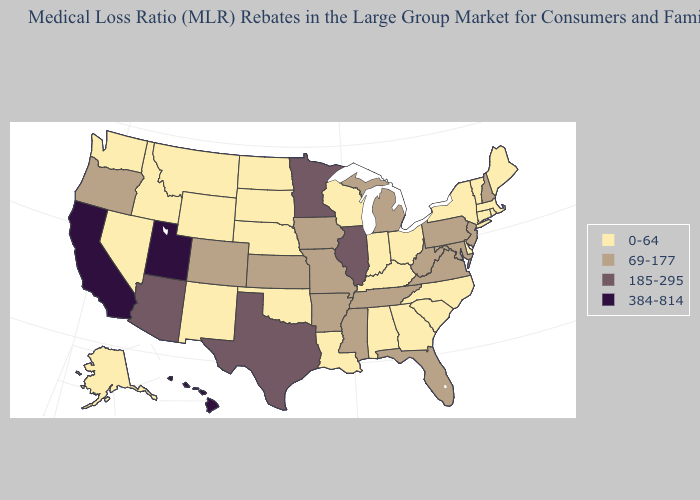Which states hav the highest value in the Northeast?
Short answer required. New Hampshire, New Jersey, Pennsylvania. Name the states that have a value in the range 0-64?
Be succinct. Alabama, Alaska, Connecticut, Delaware, Georgia, Idaho, Indiana, Kentucky, Louisiana, Maine, Massachusetts, Montana, Nebraska, Nevada, New Mexico, New York, North Carolina, North Dakota, Ohio, Oklahoma, Rhode Island, South Carolina, South Dakota, Vermont, Washington, Wisconsin, Wyoming. Does the map have missing data?
Quick response, please. No. Which states have the lowest value in the USA?
Be succinct. Alabama, Alaska, Connecticut, Delaware, Georgia, Idaho, Indiana, Kentucky, Louisiana, Maine, Massachusetts, Montana, Nebraska, Nevada, New Mexico, New York, North Carolina, North Dakota, Ohio, Oklahoma, Rhode Island, South Carolina, South Dakota, Vermont, Washington, Wisconsin, Wyoming. Name the states that have a value in the range 69-177?
Quick response, please. Arkansas, Colorado, Florida, Iowa, Kansas, Maryland, Michigan, Mississippi, Missouri, New Hampshire, New Jersey, Oregon, Pennsylvania, Tennessee, Virginia, West Virginia. What is the value of Montana?
Quick response, please. 0-64. Does Oregon have the lowest value in the USA?
Quick response, please. No. What is the value of Texas?
Answer briefly. 185-295. Among the states that border Iowa , which have the lowest value?
Answer briefly. Nebraska, South Dakota, Wisconsin. Among the states that border New Hampshire , which have the highest value?
Give a very brief answer. Maine, Massachusetts, Vermont. Name the states that have a value in the range 0-64?
Keep it brief. Alabama, Alaska, Connecticut, Delaware, Georgia, Idaho, Indiana, Kentucky, Louisiana, Maine, Massachusetts, Montana, Nebraska, Nevada, New Mexico, New York, North Carolina, North Dakota, Ohio, Oklahoma, Rhode Island, South Carolina, South Dakota, Vermont, Washington, Wisconsin, Wyoming. Which states have the lowest value in the Northeast?
Keep it brief. Connecticut, Maine, Massachusetts, New York, Rhode Island, Vermont. What is the lowest value in the South?
Answer briefly. 0-64. What is the highest value in the USA?
Write a very short answer. 384-814. 